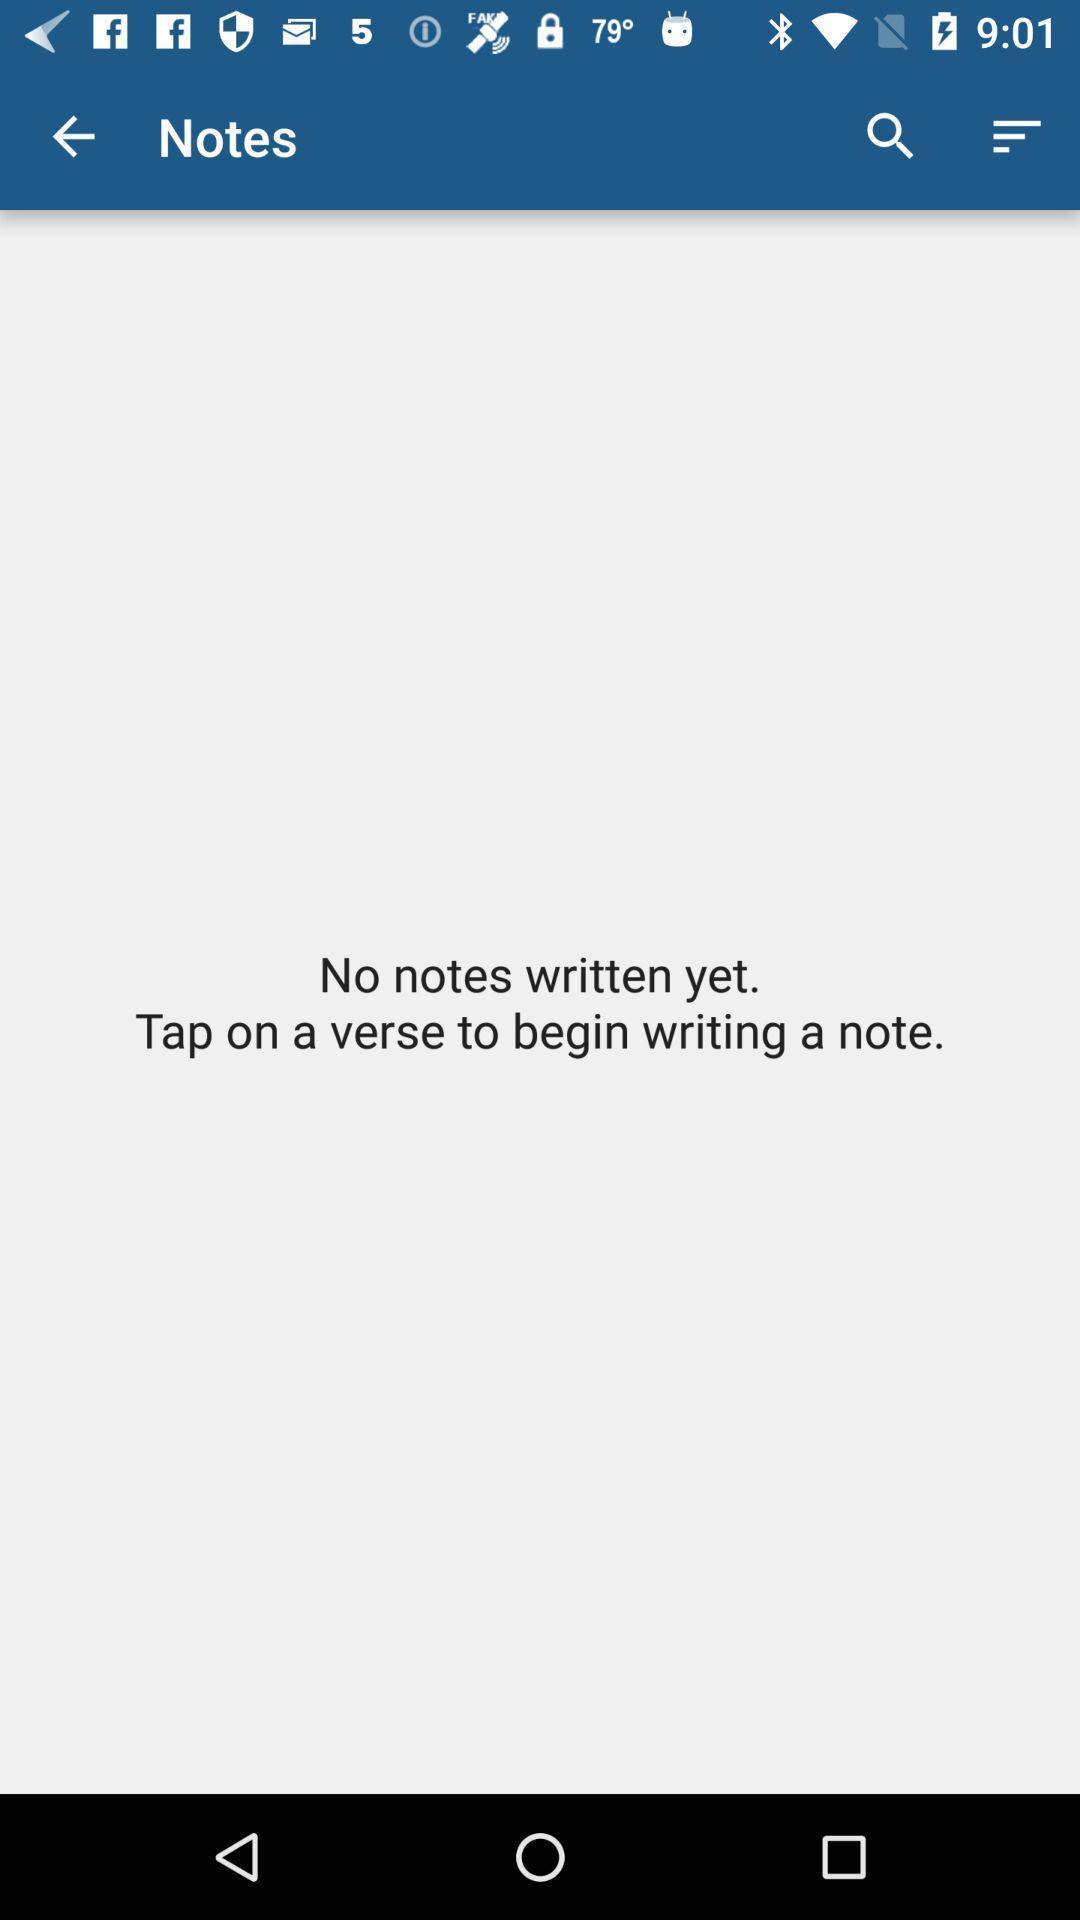Provide a description of this screenshot. Screen displaying notes page. 